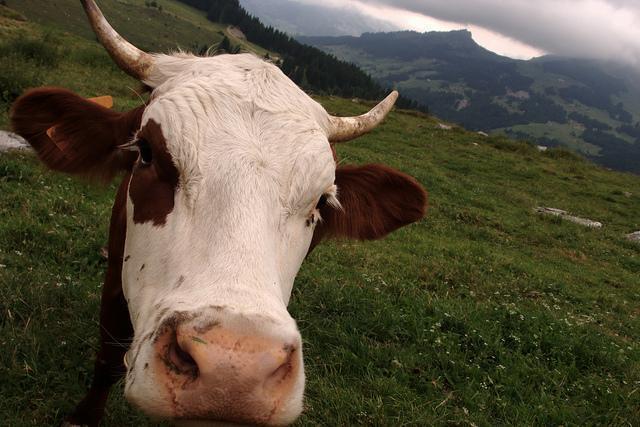How many cows have brown markings?
Give a very brief answer. 1. 